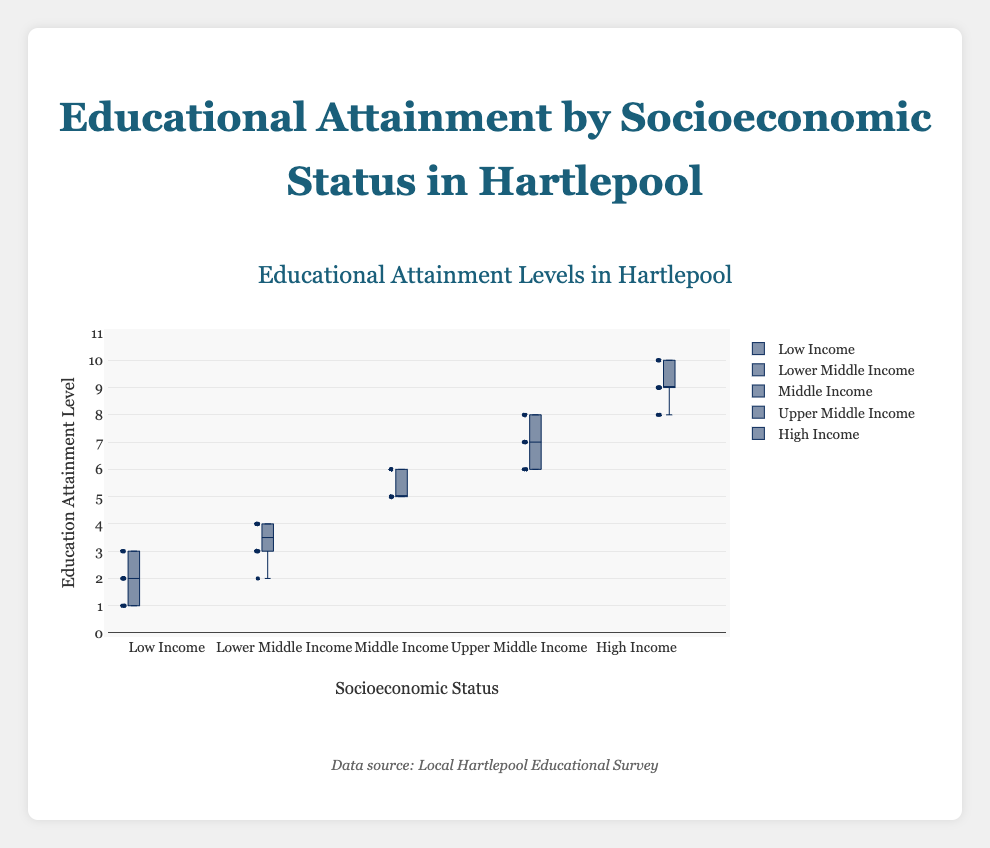What is the title of the figure? The title is located at the top of the figure and reads "Educational Attainment Levels in Hartlepool".
Answer: Educational Attainment Levels in Hartlepool What are the different socioeconomic statuses shown in the figure? The different socioeconomic statuses are listed along the x-axis as categories, and they include Low Income, Lower Middle Income, Middle Income, Upper Middle Income, and High Income.
Answer: Low Income, Lower Middle Income, Middle Income, Upper Middle Income, High Income What is the range of education attainment levels shown on the y-axis? The y-axis range is specified from 0 to 11, as indicated by the axis ticks.
Answer: 0 to 11 What is the median education attainment level for the High Income group? The median value for a box plot is represented by the line inside the box. For the High Income group, the median is around 9.
Answer: 9 Which socioeconomic status has the highest median education attainment level? By comparing the median lines inside the boxes of all groups, the High Income group has the highest median, with a value around 9.
Answer: High Income What is the interquartile range (IQR) of the education attainment level for the Upper Middle Income group? IQR is the range between the first quartile (Q1) and the third quartile (Q3), represented by the lower and upper edges of the box. For Upper Middle Income, Q1 is around 6 and Q3 is around 8, so the IQR is 8 - 6 = 2.
Answer: 2 Which group has the widest spread in education attainment levels? The spread of data can be observed by the length of the whiskers which indicate the range. The High Income group has the widest spread from 8 to 10.
Answer: High Income How many outliers can you identify in the Middle Income group? In a box plot, outliers are shown as individual points outside the whiskers. The Middle Income group has no visible outliers.
Answer: 0 Compare the median education attainment for Low Income and Lower Middle Income groups. The median for Low Income is around 2, and for Lower Middle Income, it’s around 4, hence Lower Middle Income has a higher median education attainment level.
Answer: Lower Middle Income What can you infer about the relationship between socioeconomic status and education attainment from this figure? As socioeconomic status increases from Low Income to High Income, the median education attainment levels also increase, showing a positive relationship. Higher socioeconomic status tends to coincide with higher education attainment levels.
Answer: Positive relationship 